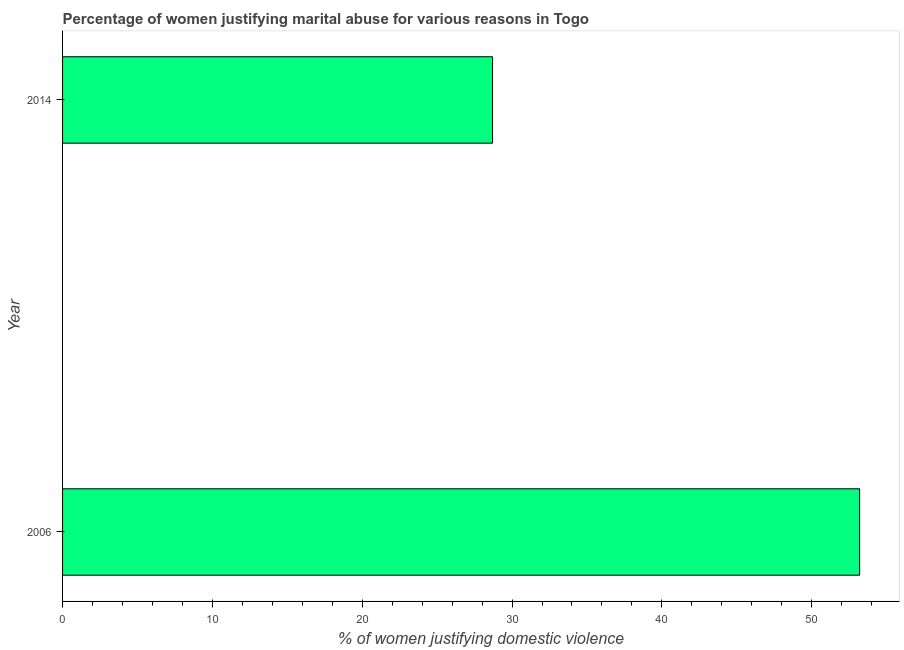Does the graph contain any zero values?
Your answer should be compact. No. Does the graph contain grids?
Your answer should be compact. No. What is the title of the graph?
Offer a terse response. Percentage of women justifying marital abuse for various reasons in Togo. What is the label or title of the X-axis?
Keep it short and to the point. % of women justifying domestic violence. What is the label or title of the Y-axis?
Ensure brevity in your answer.  Year. What is the percentage of women justifying marital abuse in 2014?
Your answer should be very brief. 28.7. Across all years, what is the maximum percentage of women justifying marital abuse?
Your answer should be very brief. 53.2. Across all years, what is the minimum percentage of women justifying marital abuse?
Make the answer very short. 28.7. In which year was the percentage of women justifying marital abuse maximum?
Keep it short and to the point. 2006. What is the sum of the percentage of women justifying marital abuse?
Ensure brevity in your answer.  81.9. What is the difference between the percentage of women justifying marital abuse in 2006 and 2014?
Provide a short and direct response. 24.5. What is the average percentage of women justifying marital abuse per year?
Your response must be concise. 40.95. What is the median percentage of women justifying marital abuse?
Offer a very short reply. 40.95. In how many years, is the percentage of women justifying marital abuse greater than 36 %?
Offer a very short reply. 1. What is the ratio of the percentage of women justifying marital abuse in 2006 to that in 2014?
Your answer should be very brief. 1.85. Are all the bars in the graph horizontal?
Make the answer very short. Yes. How many years are there in the graph?
Keep it short and to the point. 2. What is the difference between two consecutive major ticks on the X-axis?
Keep it short and to the point. 10. What is the % of women justifying domestic violence in 2006?
Provide a succinct answer. 53.2. What is the % of women justifying domestic violence in 2014?
Keep it short and to the point. 28.7. What is the difference between the % of women justifying domestic violence in 2006 and 2014?
Keep it short and to the point. 24.5. What is the ratio of the % of women justifying domestic violence in 2006 to that in 2014?
Keep it short and to the point. 1.85. 